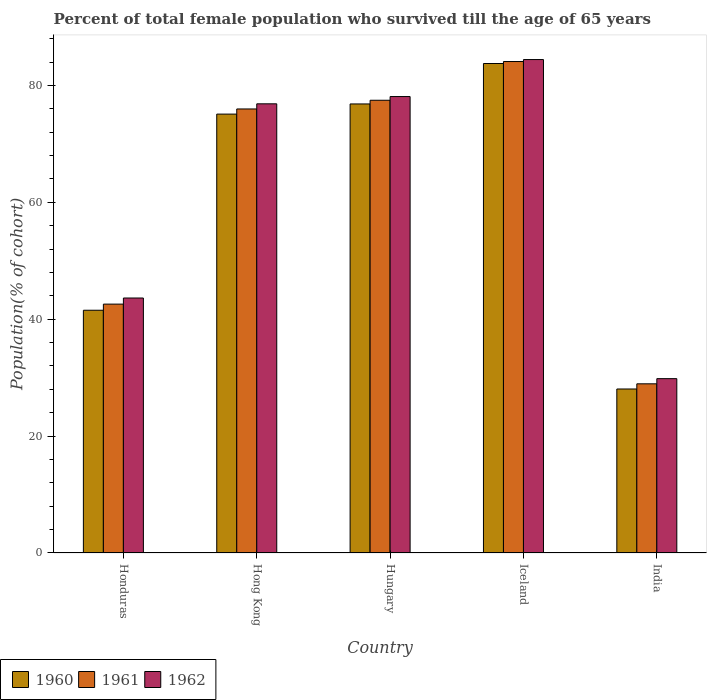Are the number of bars on each tick of the X-axis equal?
Offer a very short reply. Yes. How many bars are there on the 3rd tick from the left?
Your response must be concise. 3. What is the label of the 2nd group of bars from the left?
Offer a very short reply. Hong Kong. In how many cases, is the number of bars for a given country not equal to the number of legend labels?
Provide a short and direct response. 0. What is the percentage of total female population who survived till the age of 65 years in 1962 in Hungary?
Provide a succinct answer. 78.1. Across all countries, what is the maximum percentage of total female population who survived till the age of 65 years in 1961?
Provide a succinct answer. 84.09. Across all countries, what is the minimum percentage of total female population who survived till the age of 65 years in 1962?
Your response must be concise. 29.83. What is the total percentage of total female population who survived till the age of 65 years in 1962 in the graph?
Give a very brief answer. 312.84. What is the difference between the percentage of total female population who survived till the age of 65 years in 1962 in Honduras and that in India?
Offer a terse response. 13.8. What is the difference between the percentage of total female population who survived till the age of 65 years in 1960 in Hungary and the percentage of total female population who survived till the age of 65 years in 1961 in Hong Kong?
Ensure brevity in your answer.  0.86. What is the average percentage of total female population who survived till the age of 65 years in 1961 per country?
Your answer should be compact. 61.81. What is the difference between the percentage of total female population who survived till the age of 65 years of/in 1962 and percentage of total female population who survived till the age of 65 years of/in 1961 in Hungary?
Keep it short and to the point. 0.63. What is the ratio of the percentage of total female population who survived till the age of 65 years in 1961 in Hungary to that in India?
Ensure brevity in your answer.  2.68. What is the difference between the highest and the second highest percentage of total female population who survived till the age of 65 years in 1961?
Your response must be concise. -8.12. What is the difference between the highest and the lowest percentage of total female population who survived till the age of 65 years in 1962?
Your answer should be compact. 54.6. What does the 2nd bar from the right in Honduras represents?
Your response must be concise. 1961. How many bars are there?
Give a very brief answer. 15. How many countries are there in the graph?
Offer a terse response. 5. What is the difference between two consecutive major ticks on the Y-axis?
Offer a terse response. 20. Are the values on the major ticks of Y-axis written in scientific E-notation?
Your response must be concise. No. Does the graph contain any zero values?
Provide a short and direct response. No. What is the title of the graph?
Your response must be concise. Percent of total female population who survived till the age of 65 years. What is the label or title of the Y-axis?
Make the answer very short. Population(% of cohort). What is the Population(% of cohort) in 1960 in Honduras?
Provide a short and direct response. 41.53. What is the Population(% of cohort) of 1961 in Honduras?
Your answer should be compact. 42.58. What is the Population(% of cohort) in 1962 in Honduras?
Offer a terse response. 43.63. What is the Population(% of cohort) of 1960 in Hong Kong?
Ensure brevity in your answer.  75.1. What is the Population(% of cohort) of 1961 in Hong Kong?
Ensure brevity in your answer.  75.98. What is the Population(% of cohort) in 1962 in Hong Kong?
Make the answer very short. 76.86. What is the Population(% of cohort) of 1960 in Hungary?
Provide a short and direct response. 76.83. What is the Population(% of cohort) in 1961 in Hungary?
Make the answer very short. 77.47. What is the Population(% of cohort) of 1962 in Hungary?
Provide a short and direct response. 78.1. What is the Population(% of cohort) in 1960 in Iceland?
Your answer should be very brief. 83.75. What is the Population(% of cohort) in 1961 in Iceland?
Offer a very short reply. 84.09. What is the Population(% of cohort) of 1962 in Iceland?
Give a very brief answer. 84.43. What is the Population(% of cohort) of 1960 in India?
Ensure brevity in your answer.  28.06. What is the Population(% of cohort) in 1961 in India?
Provide a short and direct response. 28.95. What is the Population(% of cohort) in 1962 in India?
Give a very brief answer. 29.83. Across all countries, what is the maximum Population(% of cohort) in 1960?
Make the answer very short. 83.75. Across all countries, what is the maximum Population(% of cohort) of 1961?
Your answer should be very brief. 84.09. Across all countries, what is the maximum Population(% of cohort) in 1962?
Give a very brief answer. 84.43. Across all countries, what is the minimum Population(% of cohort) of 1960?
Make the answer very short. 28.06. Across all countries, what is the minimum Population(% of cohort) in 1961?
Your response must be concise. 28.95. Across all countries, what is the minimum Population(% of cohort) of 1962?
Your answer should be compact. 29.83. What is the total Population(% of cohort) of 1960 in the graph?
Your answer should be compact. 305.28. What is the total Population(% of cohort) of 1961 in the graph?
Provide a short and direct response. 309.06. What is the total Population(% of cohort) of 1962 in the graph?
Make the answer very short. 312.84. What is the difference between the Population(% of cohort) in 1960 in Honduras and that in Hong Kong?
Offer a very short reply. -33.56. What is the difference between the Population(% of cohort) in 1961 in Honduras and that in Hong Kong?
Your response must be concise. -33.39. What is the difference between the Population(% of cohort) of 1962 in Honduras and that in Hong Kong?
Give a very brief answer. -33.23. What is the difference between the Population(% of cohort) of 1960 in Honduras and that in Hungary?
Offer a terse response. -35.3. What is the difference between the Population(% of cohort) in 1961 in Honduras and that in Hungary?
Your answer should be compact. -34.88. What is the difference between the Population(% of cohort) of 1962 in Honduras and that in Hungary?
Your answer should be compact. -34.47. What is the difference between the Population(% of cohort) of 1960 in Honduras and that in Iceland?
Give a very brief answer. -42.22. What is the difference between the Population(% of cohort) in 1961 in Honduras and that in Iceland?
Your response must be concise. -41.51. What is the difference between the Population(% of cohort) in 1962 in Honduras and that in Iceland?
Offer a terse response. -40.8. What is the difference between the Population(% of cohort) in 1960 in Honduras and that in India?
Your response must be concise. 13.47. What is the difference between the Population(% of cohort) in 1961 in Honduras and that in India?
Offer a very short reply. 13.64. What is the difference between the Population(% of cohort) in 1962 in Honduras and that in India?
Ensure brevity in your answer.  13.8. What is the difference between the Population(% of cohort) in 1960 in Hong Kong and that in Hungary?
Your response must be concise. -1.74. What is the difference between the Population(% of cohort) in 1961 in Hong Kong and that in Hungary?
Provide a short and direct response. -1.49. What is the difference between the Population(% of cohort) in 1962 in Hong Kong and that in Hungary?
Make the answer very short. -1.24. What is the difference between the Population(% of cohort) of 1960 in Hong Kong and that in Iceland?
Keep it short and to the point. -8.66. What is the difference between the Population(% of cohort) in 1961 in Hong Kong and that in Iceland?
Make the answer very short. -8.12. What is the difference between the Population(% of cohort) of 1962 in Hong Kong and that in Iceland?
Your response must be concise. -7.58. What is the difference between the Population(% of cohort) in 1960 in Hong Kong and that in India?
Offer a very short reply. 47.03. What is the difference between the Population(% of cohort) of 1961 in Hong Kong and that in India?
Your answer should be very brief. 47.03. What is the difference between the Population(% of cohort) of 1962 in Hong Kong and that in India?
Keep it short and to the point. 47.02. What is the difference between the Population(% of cohort) in 1960 in Hungary and that in Iceland?
Ensure brevity in your answer.  -6.92. What is the difference between the Population(% of cohort) in 1961 in Hungary and that in Iceland?
Give a very brief answer. -6.63. What is the difference between the Population(% of cohort) of 1962 in Hungary and that in Iceland?
Offer a very short reply. -6.33. What is the difference between the Population(% of cohort) in 1960 in Hungary and that in India?
Your response must be concise. 48.77. What is the difference between the Population(% of cohort) in 1961 in Hungary and that in India?
Keep it short and to the point. 48.52. What is the difference between the Population(% of cohort) of 1962 in Hungary and that in India?
Provide a short and direct response. 48.27. What is the difference between the Population(% of cohort) in 1960 in Iceland and that in India?
Ensure brevity in your answer.  55.69. What is the difference between the Population(% of cohort) of 1961 in Iceland and that in India?
Ensure brevity in your answer.  55.15. What is the difference between the Population(% of cohort) of 1962 in Iceland and that in India?
Keep it short and to the point. 54.6. What is the difference between the Population(% of cohort) of 1960 in Honduras and the Population(% of cohort) of 1961 in Hong Kong?
Your response must be concise. -34.44. What is the difference between the Population(% of cohort) of 1960 in Honduras and the Population(% of cohort) of 1962 in Hong Kong?
Offer a very short reply. -35.32. What is the difference between the Population(% of cohort) of 1961 in Honduras and the Population(% of cohort) of 1962 in Hong Kong?
Provide a short and direct response. -34.27. What is the difference between the Population(% of cohort) in 1960 in Honduras and the Population(% of cohort) in 1961 in Hungary?
Offer a very short reply. -35.93. What is the difference between the Population(% of cohort) of 1960 in Honduras and the Population(% of cohort) of 1962 in Hungary?
Provide a succinct answer. -36.56. What is the difference between the Population(% of cohort) in 1961 in Honduras and the Population(% of cohort) in 1962 in Hungary?
Your answer should be compact. -35.52. What is the difference between the Population(% of cohort) of 1960 in Honduras and the Population(% of cohort) of 1961 in Iceland?
Make the answer very short. -42.56. What is the difference between the Population(% of cohort) in 1960 in Honduras and the Population(% of cohort) in 1962 in Iceland?
Your answer should be very brief. -42.9. What is the difference between the Population(% of cohort) of 1961 in Honduras and the Population(% of cohort) of 1962 in Iceland?
Ensure brevity in your answer.  -41.85. What is the difference between the Population(% of cohort) of 1960 in Honduras and the Population(% of cohort) of 1961 in India?
Ensure brevity in your answer.  12.59. What is the difference between the Population(% of cohort) of 1960 in Honduras and the Population(% of cohort) of 1962 in India?
Offer a terse response. 11.7. What is the difference between the Population(% of cohort) of 1961 in Honduras and the Population(% of cohort) of 1962 in India?
Make the answer very short. 12.75. What is the difference between the Population(% of cohort) in 1960 in Hong Kong and the Population(% of cohort) in 1961 in Hungary?
Ensure brevity in your answer.  -2.37. What is the difference between the Population(% of cohort) in 1960 in Hong Kong and the Population(% of cohort) in 1962 in Hungary?
Make the answer very short. -3. What is the difference between the Population(% of cohort) of 1961 in Hong Kong and the Population(% of cohort) of 1962 in Hungary?
Provide a succinct answer. -2.12. What is the difference between the Population(% of cohort) in 1960 in Hong Kong and the Population(% of cohort) in 1961 in Iceland?
Keep it short and to the point. -9. What is the difference between the Population(% of cohort) in 1960 in Hong Kong and the Population(% of cohort) in 1962 in Iceland?
Your answer should be very brief. -9.34. What is the difference between the Population(% of cohort) in 1961 in Hong Kong and the Population(% of cohort) in 1962 in Iceland?
Provide a short and direct response. -8.46. What is the difference between the Population(% of cohort) of 1960 in Hong Kong and the Population(% of cohort) of 1961 in India?
Offer a very short reply. 46.15. What is the difference between the Population(% of cohort) of 1960 in Hong Kong and the Population(% of cohort) of 1962 in India?
Provide a short and direct response. 45.26. What is the difference between the Population(% of cohort) of 1961 in Hong Kong and the Population(% of cohort) of 1962 in India?
Your answer should be compact. 46.14. What is the difference between the Population(% of cohort) of 1960 in Hungary and the Population(% of cohort) of 1961 in Iceland?
Provide a short and direct response. -7.26. What is the difference between the Population(% of cohort) of 1960 in Hungary and the Population(% of cohort) of 1962 in Iceland?
Provide a short and direct response. -7.6. What is the difference between the Population(% of cohort) of 1961 in Hungary and the Population(% of cohort) of 1962 in Iceland?
Offer a very short reply. -6.96. What is the difference between the Population(% of cohort) of 1960 in Hungary and the Population(% of cohort) of 1961 in India?
Keep it short and to the point. 47.89. What is the difference between the Population(% of cohort) in 1960 in Hungary and the Population(% of cohort) in 1962 in India?
Keep it short and to the point. 47. What is the difference between the Population(% of cohort) of 1961 in Hungary and the Population(% of cohort) of 1962 in India?
Provide a short and direct response. 47.63. What is the difference between the Population(% of cohort) of 1960 in Iceland and the Population(% of cohort) of 1961 in India?
Make the answer very short. 54.81. What is the difference between the Population(% of cohort) in 1960 in Iceland and the Population(% of cohort) in 1962 in India?
Make the answer very short. 53.92. What is the difference between the Population(% of cohort) in 1961 in Iceland and the Population(% of cohort) in 1962 in India?
Keep it short and to the point. 54.26. What is the average Population(% of cohort) in 1960 per country?
Ensure brevity in your answer.  61.06. What is the average Population(% of cohort) in 1961 per country?
Provide a short and direct response. 61.81. What is the average Population(% of cohort) of 1962 per country?
Your answer should be very brief. 62.57. What is the difference between the Population(% of cohort) of 1960 and Population(% of cohort) of 1961 in Honduras?
Offer a very short reply. -1.05. What is the difference between the Population(% of cohort) of 1960 and Population(% of cohort) of 1962 in Honduras?
Provide a succinct answer. -2.09. What is the difference between the Population(% of cohort) of 1961 and Population(% of cohort) of 1962 in Honduras?
Make the answer very short. -1.05. What is the difference between the Population(% of cohort) of 1960 and Population(% of cohort) of 1961 in Hong Kong?
Give a very brief answer. -0.88. What is the difference between the Population(% of cohort) of 1960 and Population(% of cohort) of 1962 in Hong Kong?
Give a very brief answer. -1.76. What is the difference between the Population(% of cohort) in 1961 and Population(% of cohort) in 1962 in Hong Kong?
Keep it short and to the point. -0.88. What is the difference between the Population(% of cohort) of 1960 and Population(% of cohort) of 1961 in Hungary?
Make the answer very short. -0.63. What is the difference between the Population(% of cohort) in 1960 and Population(% of cohort) in 1962 in Hungary?
Keep it short and to the point. -1.26. What is the difference between the Population(% of cohort) of 1961 and Population(% of cohort) of 1962 in Hungary?
Provide a short and direct response. -0.63. What is the difference between the Population(% of cohort) in 1960 and Population(% of cohort) in 1961 in Iceland?
Keep it short and to the point. -0.34. What is the difference between the Population(% of cohort) of 1960 and Population(% of cohort) of 1962 in Iceland?
Give a very brief answer. -0.68. What is the difference between the Population(% of cohort) of 1961 and Population(% of cohort) of 1962 in Iceland?
Offer a very short reply. -0.34. What is the difference between the Population(% of cohort) in 1960 and Population(% of cohort) in 1961 in India?
Offer a terse response. -0.88. What is the difference between the Population(% of cohort) of 1960 and Population(% of cohort) of 1962 in India?
Ensure brevity in your answer.  -1.77. What is the difference between the Population(% of cohort) in 1961 and Population(% of cohort) in 1962 in India?
Keep it short and to the point. -0.88. What is the ratio of the Population(% of cohort) in 1960 in Honduras to that in Hong Kong?
Ensure brevity in your answer.  0.55. What is the ratio of the Population(% of cohort) of 1961 in Honduras to that in Hong Kong?
Give a very brief answer. 0.56. What is the ratio of the Population(% of cohort) in 1962 in Honduras to that in Hong Kong?
Make the answer very short. 0.57. What is the ratio of the Population(% of cohort) in 1960 in Honduras to that in Hungary?
Offer a very short reply. 0.54. What is the ratio of the Population(% of cohort) in 1961 in Honduras to that in Hungary?
Make the answer very short. 0.55. What is the ratio of the Population(% of cohort) in 1962 in Honduras to that in Hungary?
Make the answer very short. 0.56. What is the ratio of the Population(% of cohort) in 1960 in Honduras to that in Iceland?
Your answer should be very brief. 0.5. What is the ratio of the Population(% of cohort) in 1961 in Honduras to that in Iceland?
Your response must be concise. 0.51. What is the ratio of the Population(% of cohort) of 1962 in Honduras to that in Iceland?
Ensure brevity in your answer.  0.52. What is the ratio of the Population(% of cohort) in 1960 in Honduras to that in India?
Make the answer very short. 1.48. What is the ratio of the Population(% of cohort) in 1961 in Honduras to that in India?
Your answer should be very brief. 1.47. What is the ratio of the Population(% of cohort) in 1962 in Honduras to that in India?
Offer a terse response. 1.46. What is the ratio of the Population(% of cohort) in 1960 in Hong Kong to that in Hungary?
Offer a terse response. 0.98. What is the ratio of the Population(% of cohort) in 1961 in Hong Kong to that in Hungary?
Your answer should be compact. 0.98. What is the ratio of the Population(% of cohort) of 1962 in Hong Kong to that in Hungary?
Your response must be concise. 0.98. What is the ratio of the Population(% of cohort) in 1960 in Hong Kong to that in Iceland?
Make the answer very short. 0.9. What is the ratio of the Population(% of cohort) of 1961 in Hong Kong to that in Iceland?
Give a very brief answer. 0.9. What is the ratio of the Population(% of cohort) of 1962 in Hong Kong to that in Iceland?
Provide a succinct answer. 0.91. What is the ratio of the Population(% of cohort) of 1960 in Hong Kong to that in India?
Your response must be concise. 2.68. What is the ratio of the Population(% of cohort) in 1961 in Hong Kong to that in India?
Ensure brevity in your answer.  2.62. What is the ratio of the Population(% of cohort) of 1962 in Hong Kong to that in India?
Ensure brevity in your answer.  2.58. What is the ratio of the Population(% of cohort) in 1960 in Hungary to that in Iceland?
Your answer should be very brief. 0.92. What is the ratio of the Population(% of cohort) in 1961 in Hungary to that in Iceland?
Ensure brevity in your answer.  0.92. What is the ratio of the Population(% of cohort) in 1962 in Hungary to that in Iceland?
Offer a terse response. 0.93. What is the ratio of the Population(% of cohort) of 1960 in Hungary to that in India?
Provide a succinct answer. 2.74. What is the ratio of the Population(% of cohort) of 1961 in Hungary to that in India?
Provide a short and direct response. 2.68. What is the ratio of the Population(% of cohort) of 1962 in Hungary to that in India?
Make the answer very short. 2.62. What is the ratio of the Population(% of cohort) of 1960 in Iceland to that in India?
Your answer should be compact. 2.98. What is the ratio of the Population(% of cohort) of 1961 in Iceland to that in India?
Your answer should be very brief. 2.91. What is the ratio of the Population(% of cohort) of 1962 in Iceland to that in India?
Keep it short and to the point. 2.83. What is the difference between the highest and the second highest Population(% of cohort) in 1960?
Make the answer very short. 6.92. What is the difference between the highest and the second highest Population(% of cohort) in 1961?
Provide a short and direct response. 6.63. What is the difference between the highest and the second highest Population(% of cohort) of 1962?
Your response must be concise. 6.33. What is the difference between the highest and the lowest Population(% of cohort) of 1960?
Provide a short and direct response. 55.69. What is the difference between the highest and the lowest Population(% of cohort) of 1961?
Your answer should be compact. 55.15. What is the difference between the highest and the lowest Population(% of cohort) in 1962?
Ensure brevity in your answer.  54.6. 